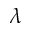Convert formula to latex. <formula><loc_0><loc_0><loc_500><loc_500>\lambda</formula> 